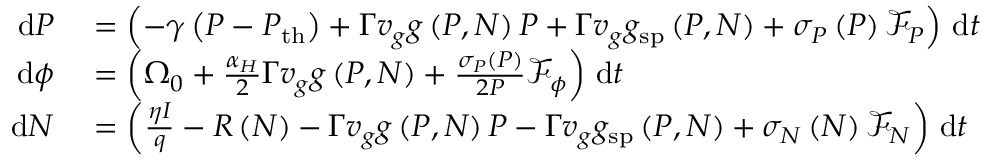<formula> <loc_0><loc_0><loc_500><loc_500>\begin{array} { r l } { d P } & = \left ( - \gamma \left ( P - P _ { t h } \right ) + \Gamma v _ { g } g \left ( P , N \right ) P + \Gamma v _ { g } g _ { s p } \left ( P , N \right ) + \sigma _ { P } \left ( P \right ) \mathcal { F } _ { P } \right ) \, d t } \\ { d \phi } & = \left ( \Omega _ { 0 } + \frac { \alpha _ { H } } { 2 } \Gamma v _ { g } g \left ( P , N \right ) + \frac { \sigma _ { P } \left ( P \right ) } { 2 P } \mathcal { F } _ { \phi } \right ) \, d t } \\ { d N } & = \left ( \frac { \eta I } { q } - R \left ( N \right ) - \Gamma v _ { g } g \left ( P , N \right ) P - \Gamma v _ { g } g _ { s p } \left ( P , N \right ) + \sigma _ { N } \left ( N \right ) \mathcal { F } _ { N } \right ) \, d t } \end{array}</formula> 